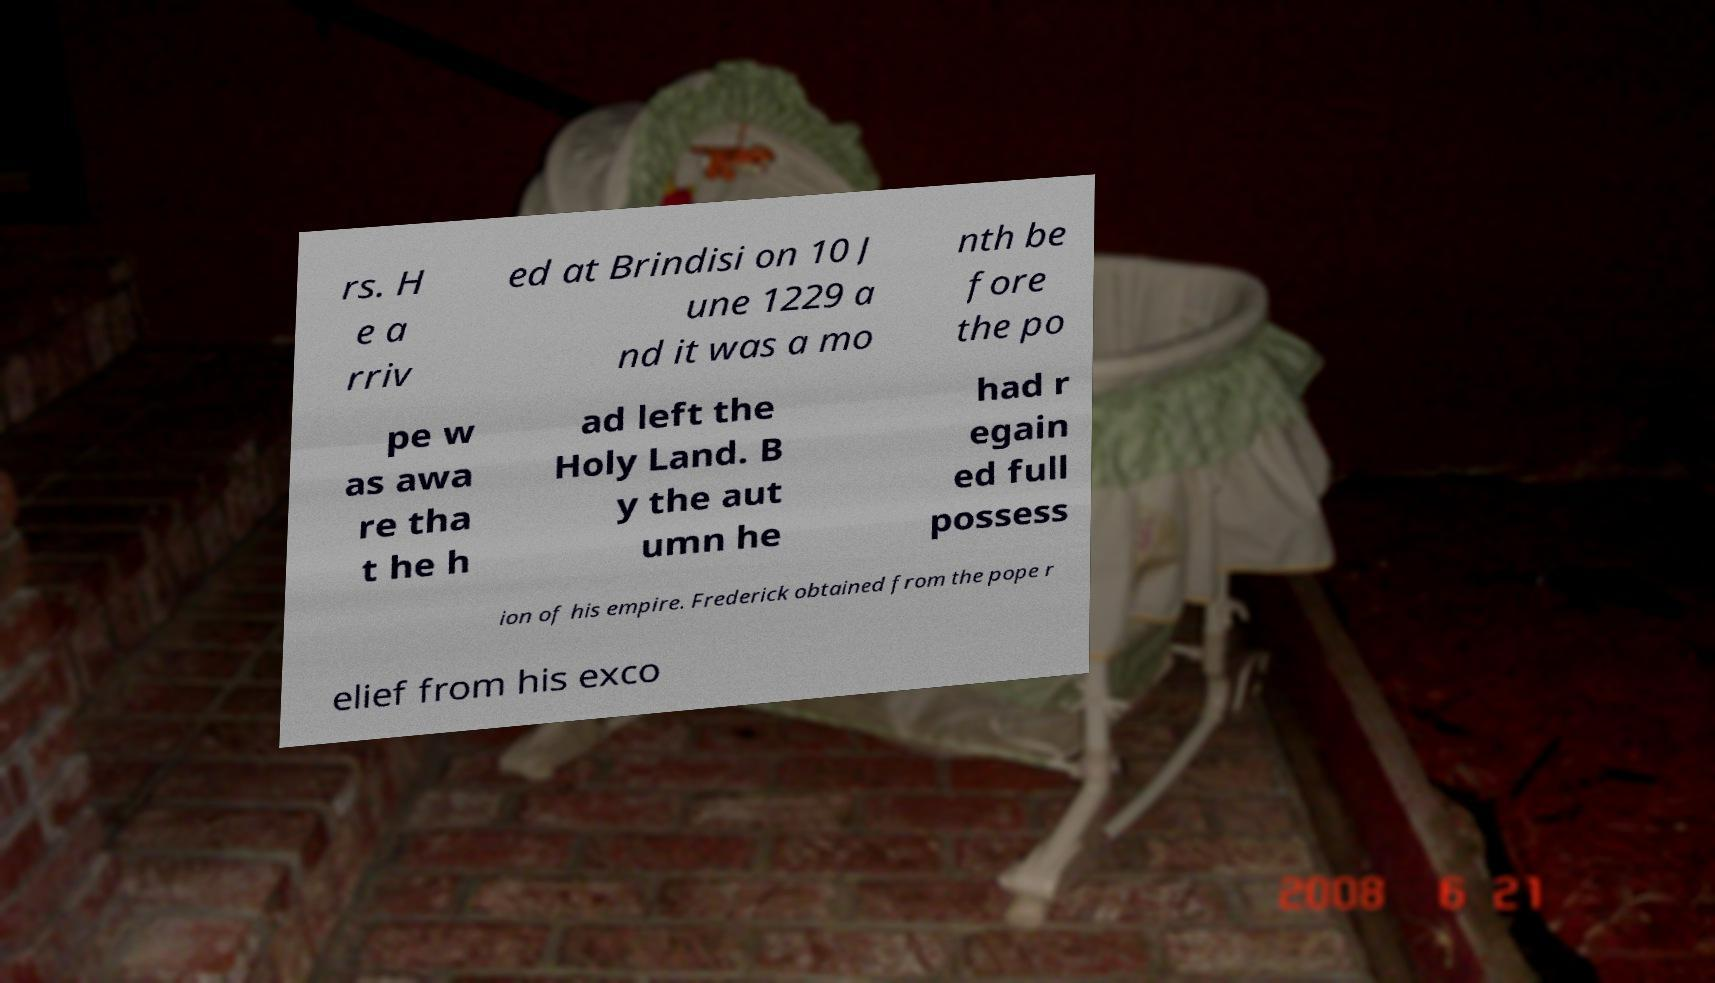There's text embedded in this image that I need extracted. Can you transcribe it verbatim? rs. H e a rriv ed at Brindisi on 10 J une 1229 a nd it was a mo nth be fore the po pe w as awa re tha t he h ad left the Holy Land. B y the aut umn he had r egain ed full possess ion of his empire. Frederick obtained from the pope r elief from his exco 